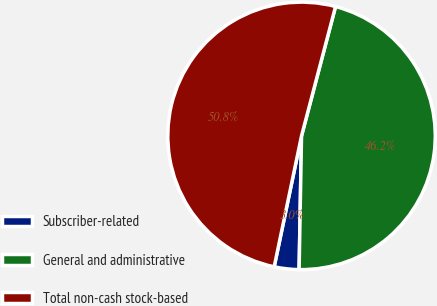<chart> <loc_0><loc_0><loc_500><loc_500><pie_chart><fcel>Subscriber-related<fcel>General and administrative<fcel>Total non-cash stock-based<nl><fcel>2.99%<fcel>46.2%<fcel>50.82%<nl></chart> 